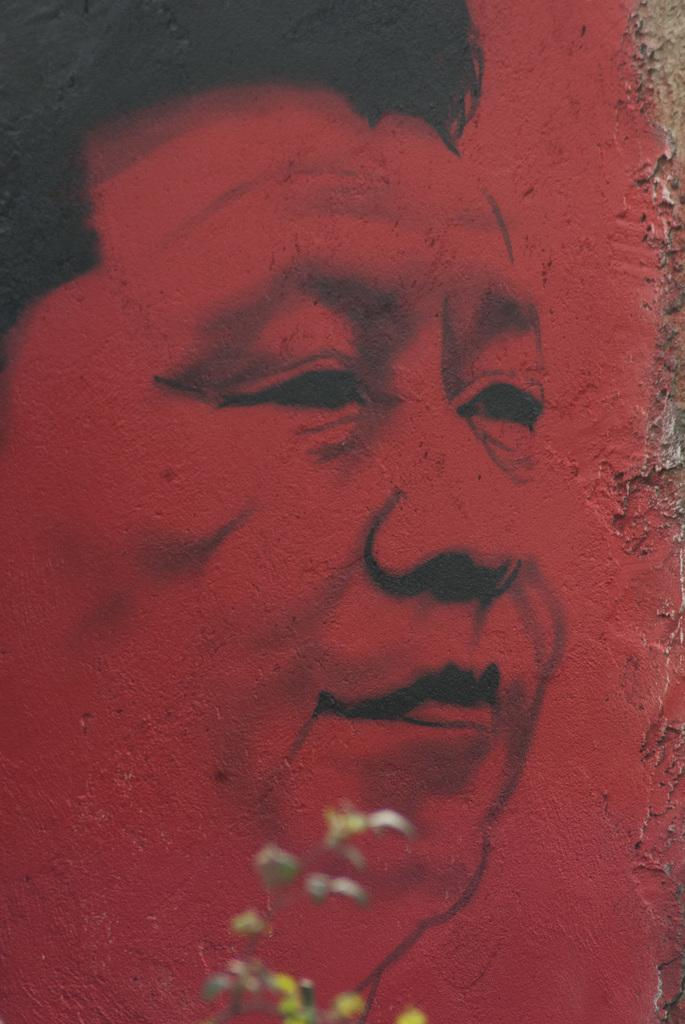What is the main subject of the image? There is a painting in the image. What is depicted in the painting? The painting depicts a person. What color is the person in the painting? The person in the painting is in red color. How many glasses of wine are on the table next to the painting? There is no table or glasses of wine present in the image; it only features a painting of a person in red color. 